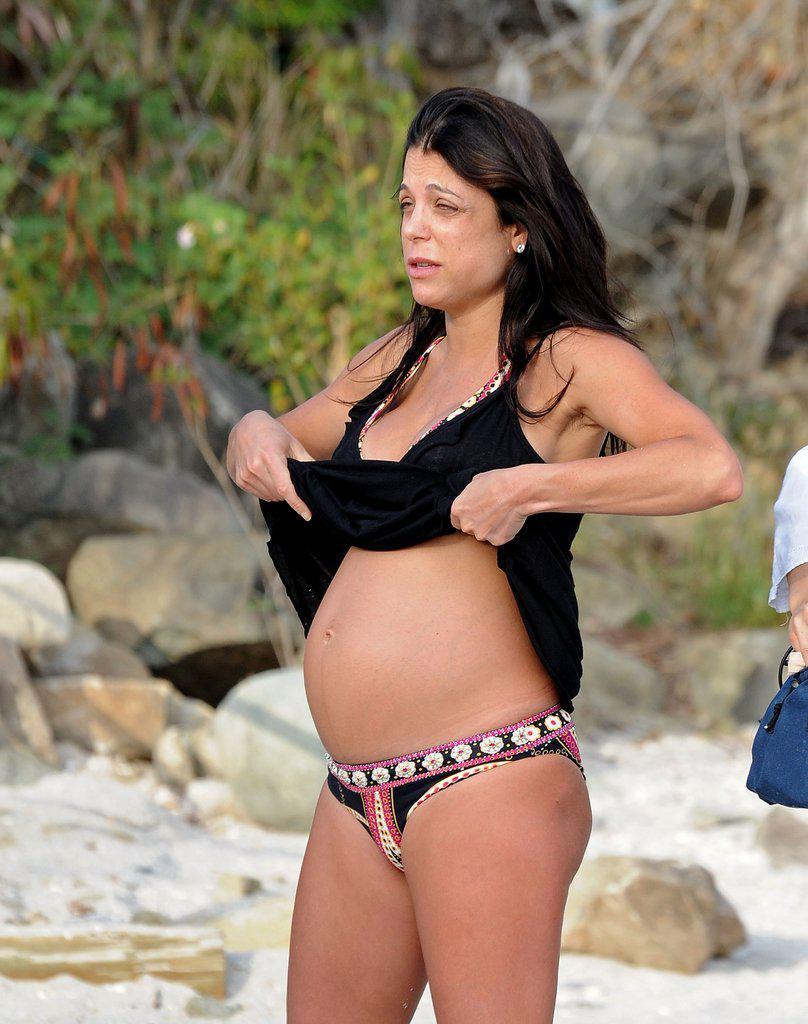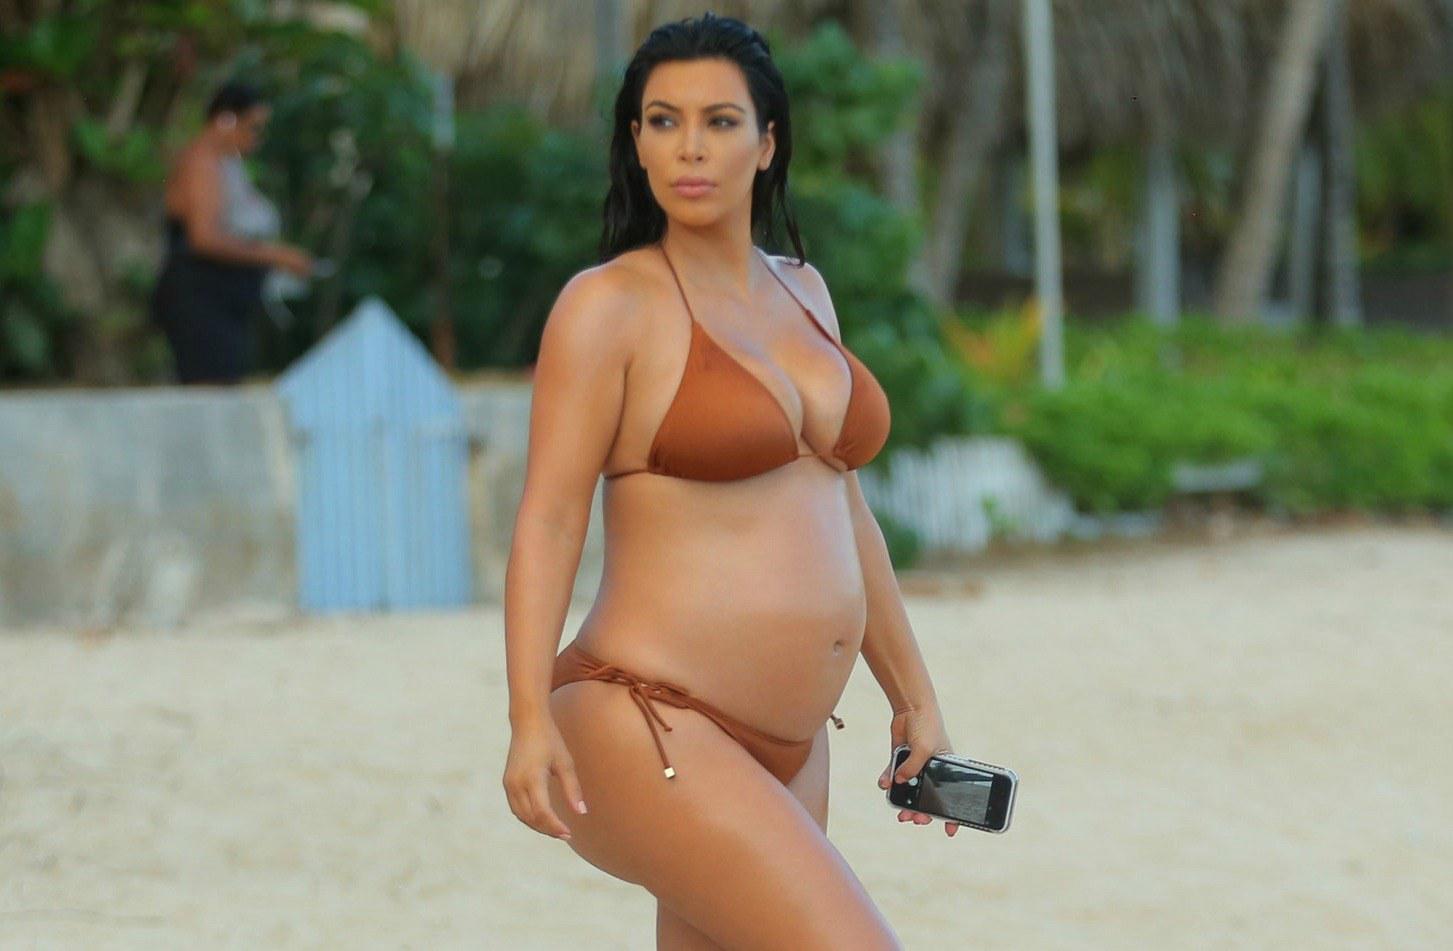The first image is the image on the left, the second image is the image on the right. Given the left and right images, does the statement "The woman in the image on the right is wearing a white bikini." hold true? Answer yes or no. No. The first image is the image on the left, the second image is the image on the right. Considering the images on both sides, is "There is a woman with at least one of her hands touching her hair." valid? Answer yes or no. No. 